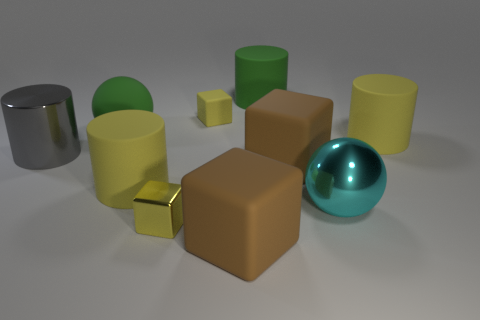There is a sphere that is left of the brown object in front of the big cyan sphere; what number of big gray shiny cylinders are behind it?
Your answer should be very brief. 0. The small object right of the small block in front of the large cyan shiny thing is what color?
Your answer should be very brief. Yellow. How many other things are made of the same material as the big cyan sphere?
Make the answer very short. 2. What number of brown rubber cubes are in front of the tiny block in front of the big cyan metal object?
Give a very brief answer. 1. There is a sphere on the left side of the small rubber object; is its color the same as the cylinder behind the tiny yellow rubber thing?
Offer a very short reply. Yes. Are there fewer small yellow matte blocks than red shiny objects?
Provide a short and direct response. No. What is the shape of the large yellow thing that is in front of the yellow thing that is to the right of the tiny rubber block?
Ensure brevity in your answer.  Cylinder. There is a large metal object behind the large sphere that is on the right side of the tiny yellow thing in front of the large gray metallic cylinder; what shape is it?
Ensure brevity in your answer.  Cylinder. What number of things are either yellow objects behind the shiny cube or metallic objects behind the metal ball?
Your answer should be very brief. 4. There is a matte ball; is its size the same as the shiny cube that is on the left side of the cyan shiny thing?
Keep it short and to the point. No. 